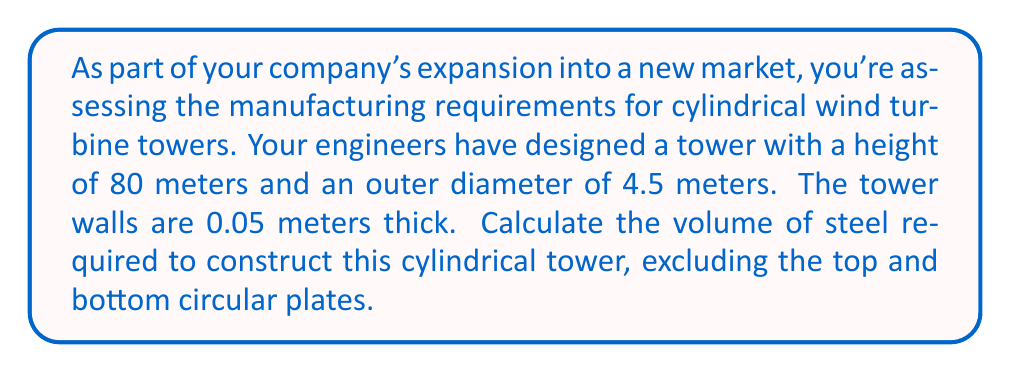Can you answer this question? To solve this problem, we need to calculate the volume of the entire cylinder and subtract the volume of the hollow inner part. Let's break it down step-by-step:

1. Calculate the outer volume:
   The volume of a cylinder is given by $V = \pi r^2 h$, where $r$ is the radius and $h$ is the height.
   
   Outer radius: $r_o = 4.5 / 2 = 2.25$ meters
   $$V_{outer} = \pi (2.25 \text{ m})^2 (80 \text{ m}) = 1272.35 \text{ m}^3$$

2. Calculate the inner volume:
   The inner radius is 0.05 meters less than the outer radius due to the wall thickness.
   Inner radius: $r_i = 2.25 - 0.05 = 2.2$ meters
   $$V_{inner} = \pi (2.2 \text{ m})^2 (80 \text{ m}) = 1216.69 \text{ m}^3$$

3. Calculate the volume of steel required:
   This is the difference between the outer and inner volumes.
   $$V_{steel} = V_{outer} - V_{inner} = 1272.35 \text{ m}^3 - 1216.69 \text{ m}^3 = 55.66 \text{ m}^3$$

Therefore, the volume of steel required to construct the cylindrical tower is approximately 55.66 cubic meters.
Answer: $55.66 \text{ m}^3$ 